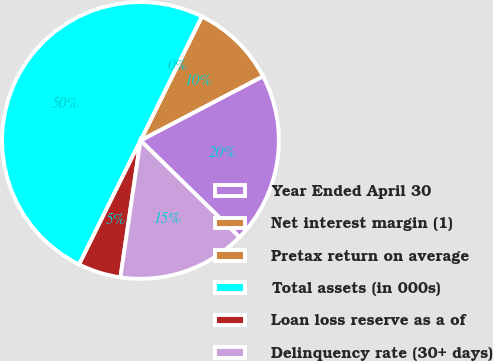Convert chart to OTSL. <chart><loc_0><loc_0><loc_500><loc_500><pie_chart><fcel>Year Ended April 30<fcel>Net interest margin (1)<fcel>Pretax return on average<fcel>Total assets (in 000s)<fcel>Loan loss reserve as a of<fcel>Delinquency rate (30+ days)<nl><fcel>20.0%<fcel>10.0%<fcel>0.0%<fcel>50.0%<fcel>5.0%<fcel>15.0%<nl></chart> 